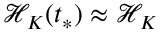Convert formula to latex. <formula><loc_0><loc_0><loc_500><loc_500>\mathcal { H } _ { K } ( t _ { * } ) \approx \mathcal { H } _ { K }</formula> 